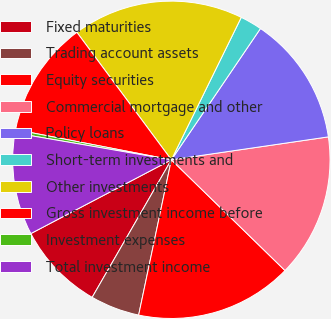Convert chart. <chart><loc_0><loc_0><loc_500><loc_500><pie_chart><fcel>Fixed maturities<fcel>Trading account assets<fcel>Equity securities<fcel>Commercial mortgage and other<fcel>Policy loans<fcel>Short-term investments and<fcel>Other investments<fcel>Gross investment income before<fcel>Investment expenses<fcel>Total investment income<nl><fcel>8.99%<fcel>5.01%<fcel>16.01%<fcel>14.6%<fcel>13.2%<fcel>2.23%<fcel>17.41%<fcel>11.8%<fcel>0.34%<fcel>10.4%<nl></chart> 